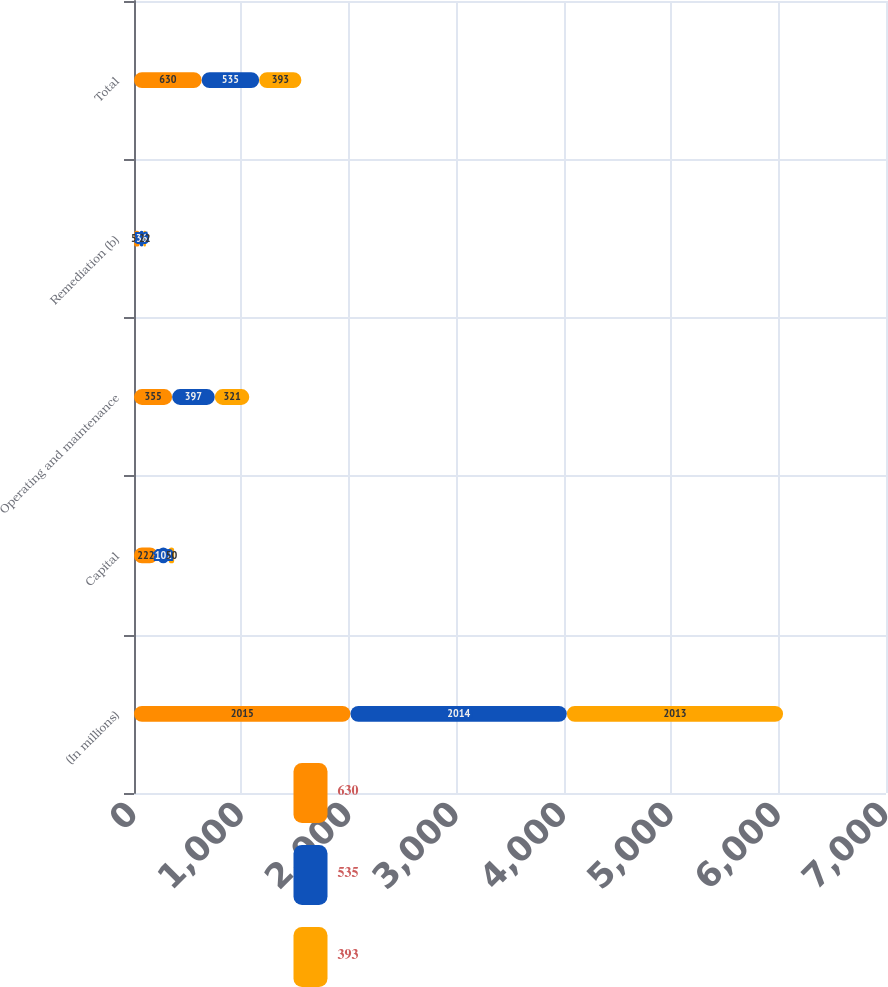<chart> <loc_0><loc_0><loc_500><loc_500><stacked_bar_chart><ecel><fcel>(In millions)<fcel>Capital<fcel>Operating and maintenance<fcel>Remediation (b)<fcel>Total<nl><fcel>630<fcel>2015<fcel>222<fcel>355<fcel>53<fcel>630<nl><fcel>535<fcel>2014<fcel>102<fcel>397<fcel>36<fcel>535<nl><fcel>393<fcel>2013<fcel>50<fcel>321<fcel>22<fcel>393<nl></chart> 